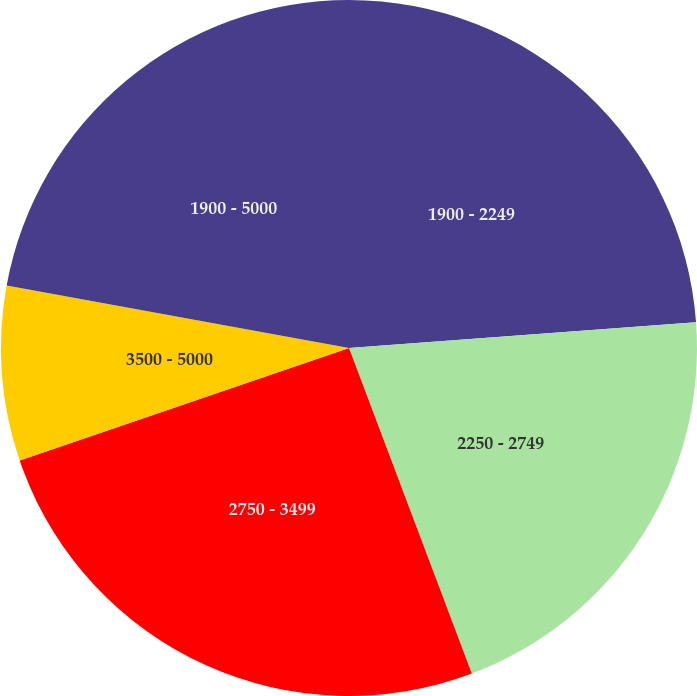Convert chart to OTSL. <chart><loc_0><loc_0><loc_500><loc_500><pie_chart><fcel>1900 - 2249<fcel>2250 - 2749<fcel>2750 - 3499<fcel>3500 - 5000<fcel>1900 - 5000<nl><fcel>23.82%<fcel>20.44%<fcel>25.5%<fcel>8.11%<fcel>22.13%<nl></chart> 